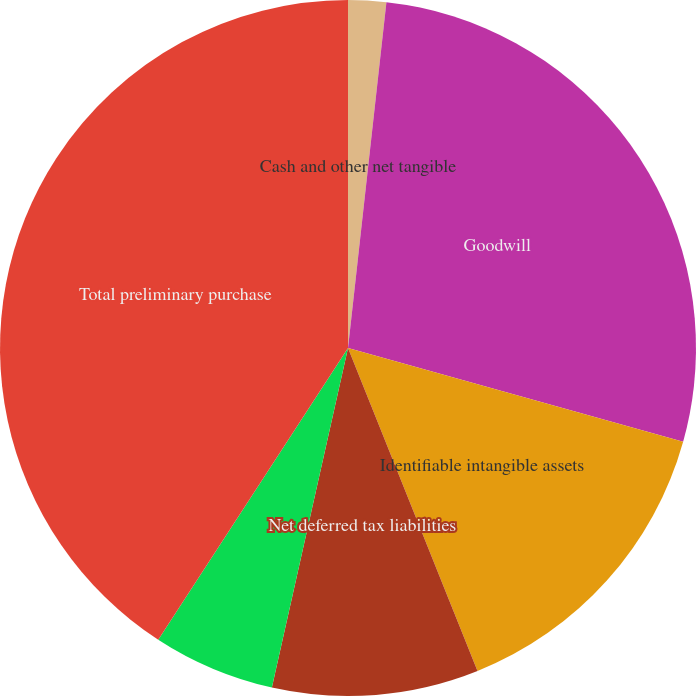Convert chart to OTSL. <chart><loc_0><loc_0><loc_500><loc_500><pie_chart><fcel>Cash and other net tangible<fcel>Goodwill<fcel>Identifiable intangible assets<fcel>Net deferred tax liabilities<fcel>In-process research and<fcel>Total preliminary purchase<nl><fcel>1.76%<fcel>27.58%<fcel>14.59%<fcel>9.58%<fcel>5.67%<fcel>40.82%<nl></chart> 